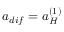<formula> <loc_0><loc_0><loc_500><loc_500>a _ { d i f } = a _ { H } ^ { ( 1 ) }</formula> 